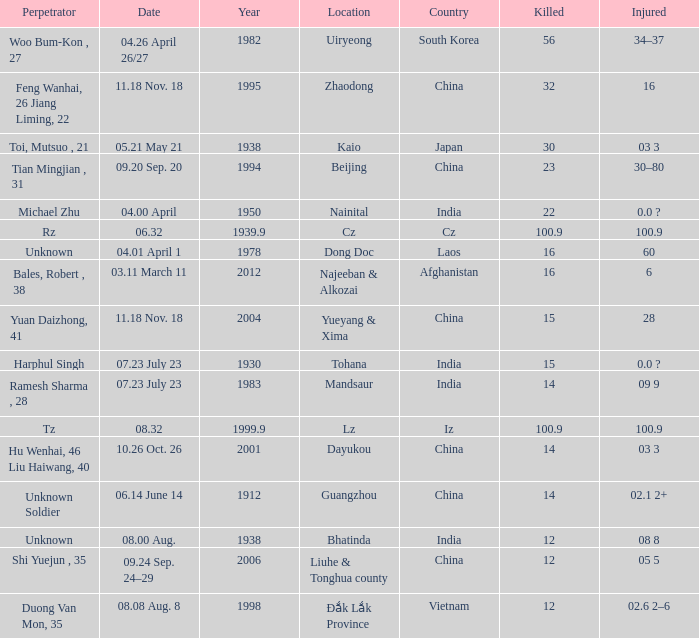What is the average year for the date "0 1978.0. 